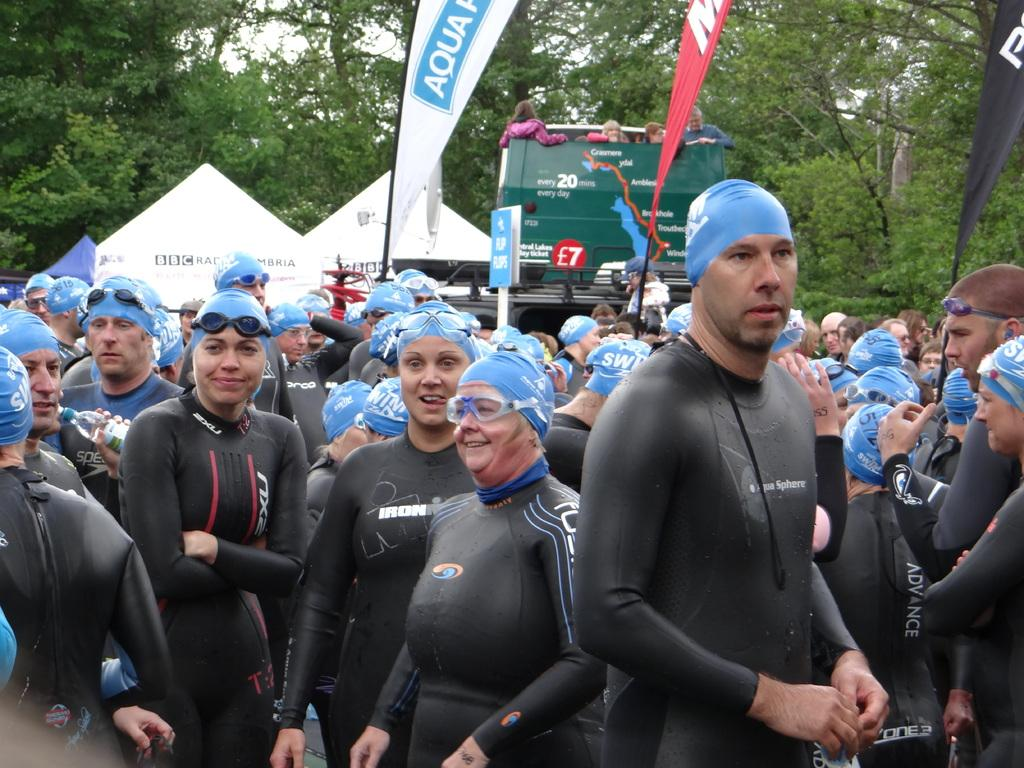How many people are present in the image? There are many people in the image. What else can be seen besides the people? There are two vehicles, two tents, many trees, and three advertising flags in the image. What type of profit can be seen from the mice in the image? There are no mice present in the image, so it is not possible to determine any profit related to them. 